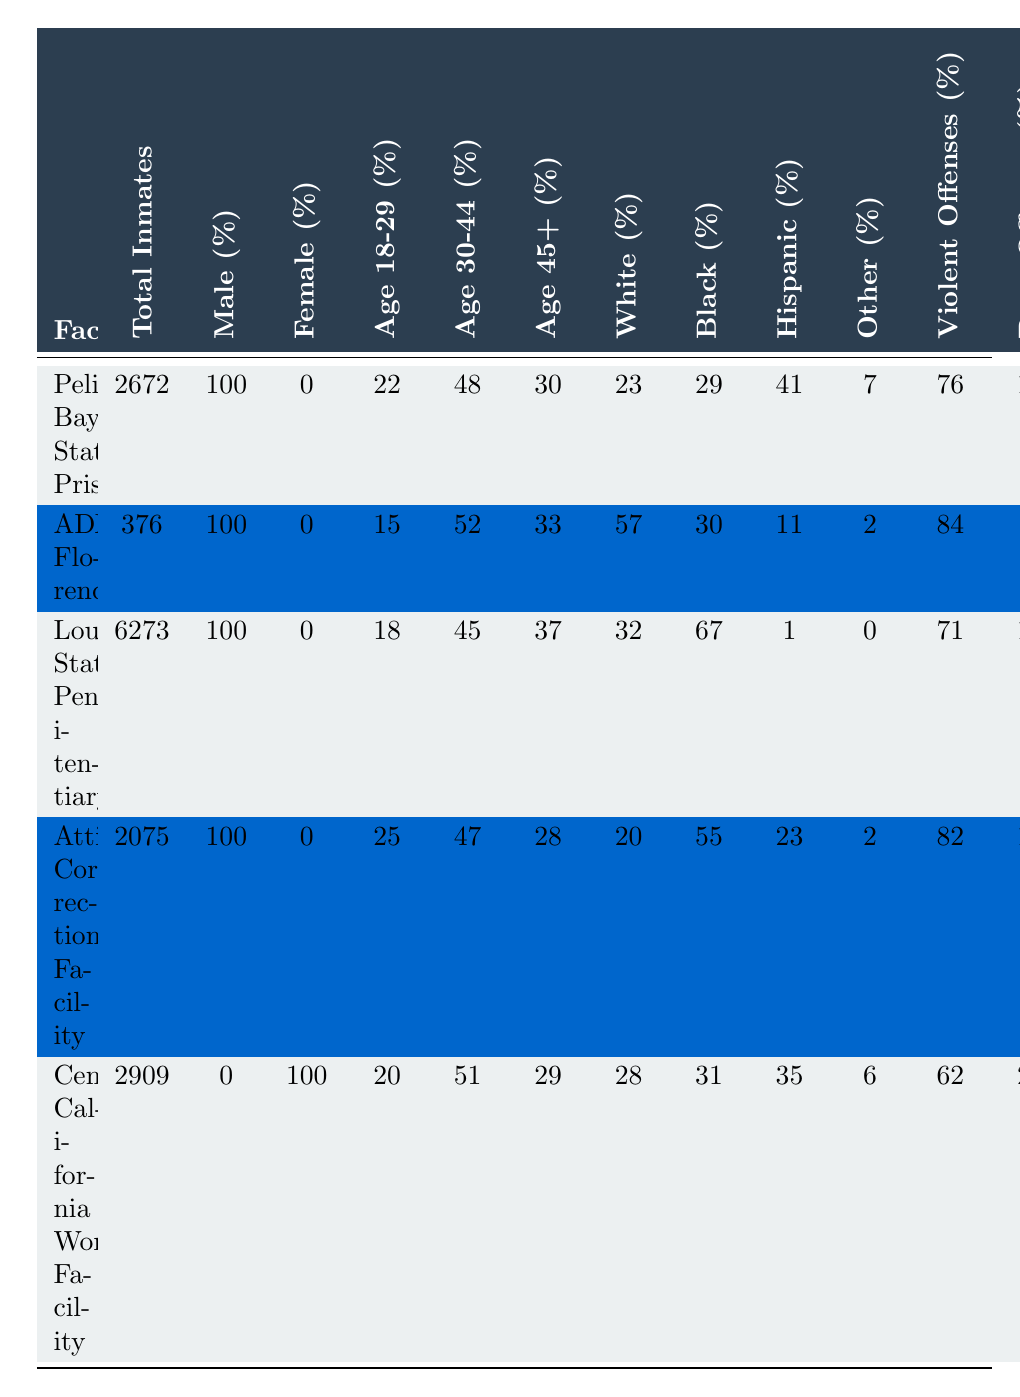What percentage of inmates are gang affiliated in Pelican Bay State Prison? The table shows that 65% of inmates in Pelican Bay State Prison are gang affiliated as directly specified in the "Gang Affiliated (%)" column.
Answer: 65% What is the average sentence length for inmates in Louisiana State Penitentiary? The average sentence length for inmates in Louisiana State Penitentiary is directly listed as 32.8 years in the "Avg Sentence (years)" column.
Answer: 32.8 years Which facility has the highest percentage of violent offenses? By comparing the "Violent Offenses (%)" column, ADX Florence has the highest percentage of violent offenses at 84%.
Answer: ADX Florence How many total inmates are in all the facilities combined? Summing up the "Total Inmates" values gives 2672 + 376 + 6273 + 2075 + 2909 = 14405 total inmates across all facilities.
Answer: 14405 Is the percentage of female inmates in Central California Women's Facility 100%? The table indicates that Central California Women's Facility has 100% female inmates, as shown in the "Female (%)" column.
Answer: Yes What is the average percentage of Hispanic inmates across all facilities? The Hispanic percentages are: 41%, 11%, 1%, 23%, and 35%. The average is (41 + 11 + 1 + 23 + 35) / 5 = 22.2%.
Answer: 22.2% In which facility is the average sentence longer: Attica Correctional Facility or Pelican Bay State Prison? Attica Correctional Facility has an average sentence of 25.6 years while Pelican Bay State Prison has 27.5 years, making Pelican Bay's average longer.
Answer: Pelican Bay State Prison What is the percentage of males in Louisiana State Penitentiary? The table indicates that 100% of inmates in Louisiana State Penitentiary are male, as shown in the "Male (%)" column.
Answer: 100% Which facility has the lowest percentage of drug offenses? The facility with the lowest percentage of drug offenses is Louisiana State Penitentiary, with only 17% as stated in the "Drug Offenses (%)" column.
Answer: Louisiana State Penitentiary How does the percentage of Black inmates compare between Attica Correctional Facility and ADX Florence? Attica Correctional Facility has 55% Black inmates while ADX Florence has 30%. Therefore, Attica has a higher percentage of Black inmates.
Answer: Attica Correctional Facility has a higher percentage 